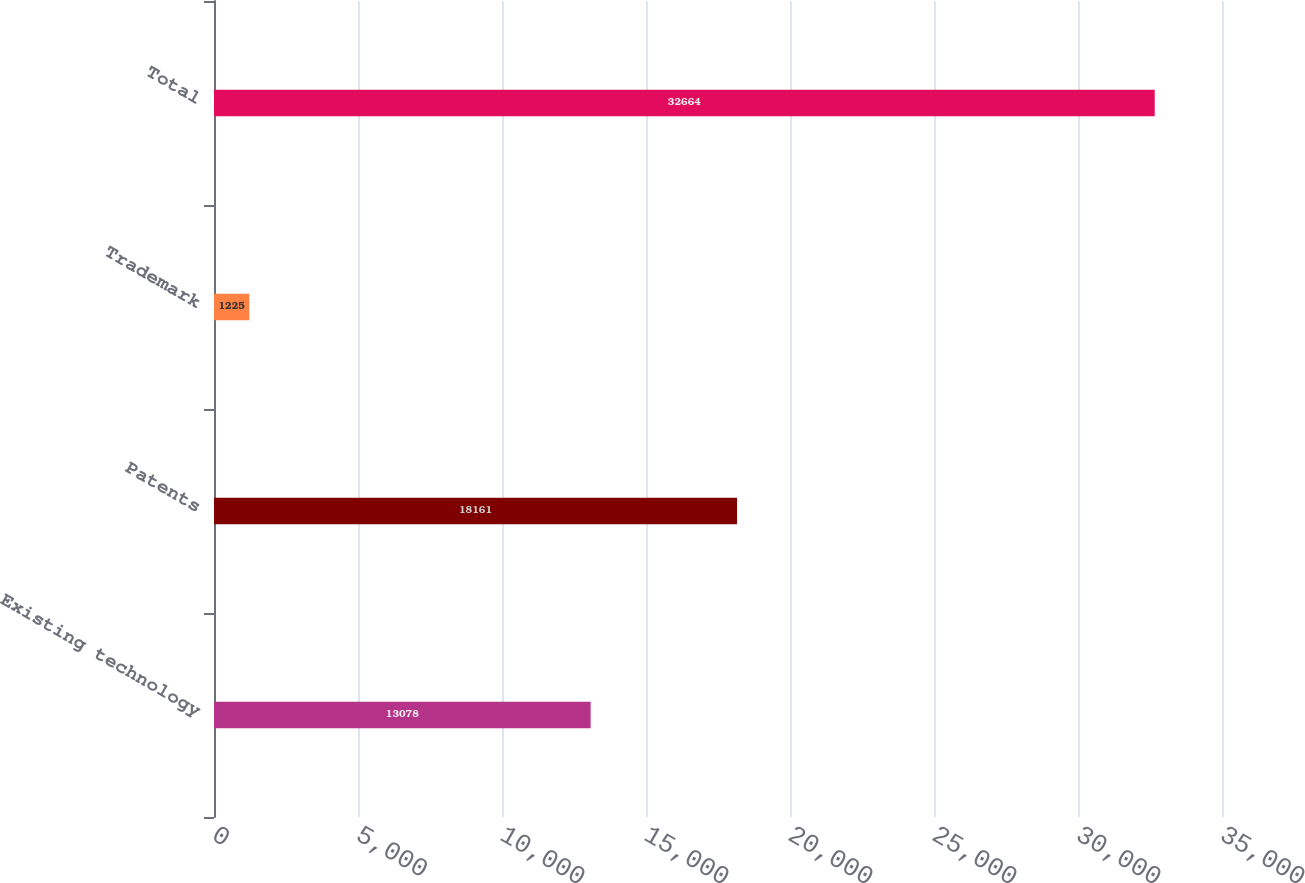Convert chart. <chart><loc_0><loc_0><loc_500><loc_500><bar_chart><fcel>Existing technology<fcel>Patents<fcel>Trademark<fcel>Total<nl><fcel>13078<fcel>18161<fcel>1225<fcel>32664<nl></chart> 